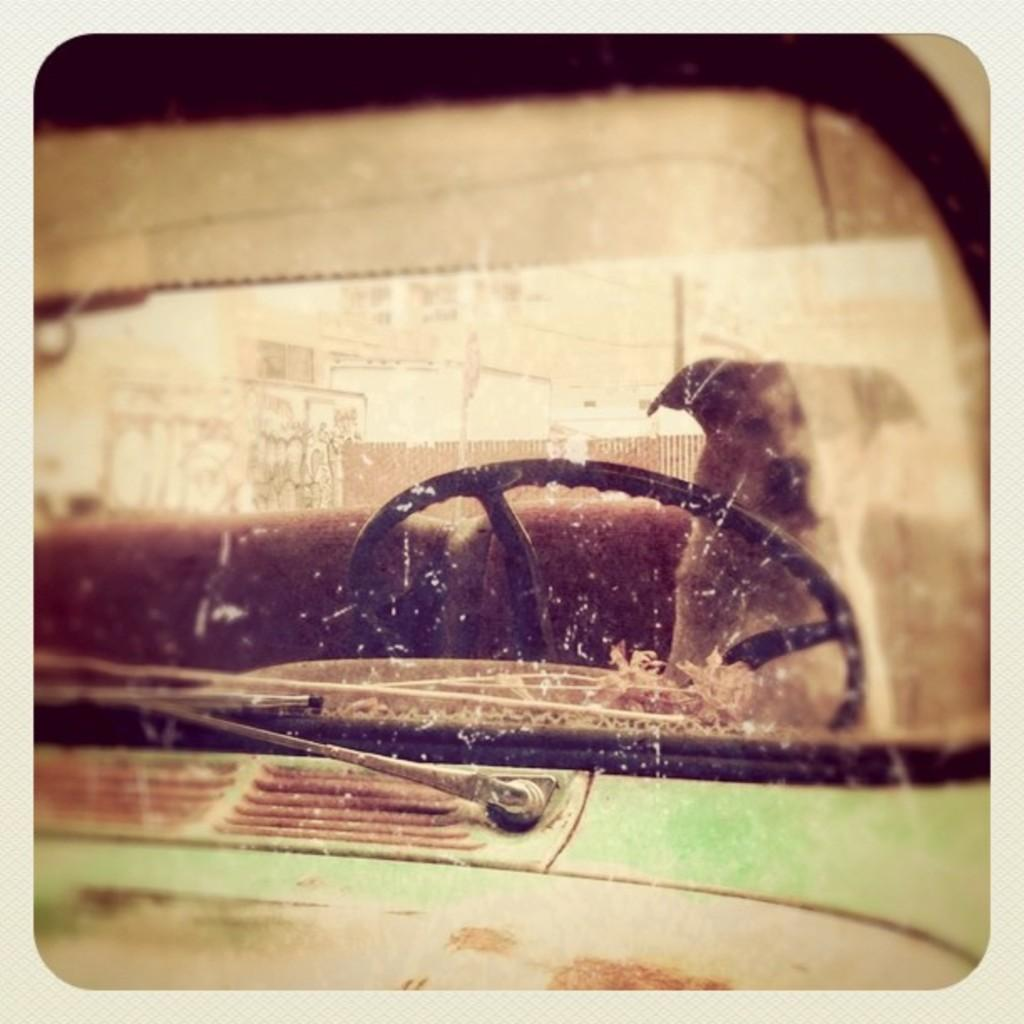What is inside the motor vehicle in the image? There is a dog in the motor vehicle. What can be seen in the distance in the image? There are buildings in the background of the image. What type of architectural feature is present in the background? There is an iron grill in the background of the image. What type of island can be seen in the background of the image? There is no island present in the image; it features a dog in a motor vehicle and buildings in the background. 